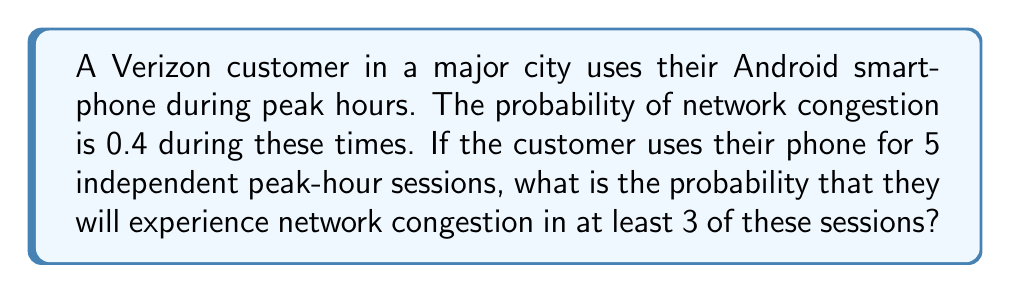Can you answer this question? To solve this problem, we can use the binomial probability distribution:

1) Let X be the number of sessions with network congestion.
   X follows a binomial distribution with n = 5 (number of sessions) and p = 0.4 (probability of congestion in each session).

2) We need to find P(X ≥ 3), which is equivalent to 1 - P(X < 3) or 1 - [P(X = 0) + P(X = 1) + P(X = 2)]

3) The probability mass function for a binomial distribution is:

   $$P(X = k) = \binom{n}{k} p^k (1-p)^{n-k}$$

4) Let's calculate each probability:

   P(X = 0) = $\binom{5}{0} (0.4)^0 (0.6)^5 = 1 \cdot 1 \cdot 0.07776 = 0.07776$
   
   P(X = 1) = $\binom{5}{1} (0.4)^1 (0.6)^4 = 5 \cdot 0.4 \cdot 0.1296 = 0.2592$
   
   P(X = 2) = $\binom{5}{2} (0.4)^2 (0.6)^3 = 10 \cdot 0.16 \cdot 0.216 = 0.3456$

5) Now, we can calculate P(X ≥ 3):

   P(X ≥ 3) = 1 - [P(X = 0) + P(X = 1) + P(X = 2)]
             = 1 - (0.07776 + 0.2592 + 0.3456)
             = 1 - 0.68256
             = 0.31744

Therefore, the probability of experiencing network congestion in at least 3 out of 5 peak-hour sessions is approximately 0.3174 or 31.74%.
Answer: 0.3174 